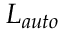Convert formula to latex. <formula><loc_0><loc_0><loc_500><loc_500>L _ { a u t o }</formula> 